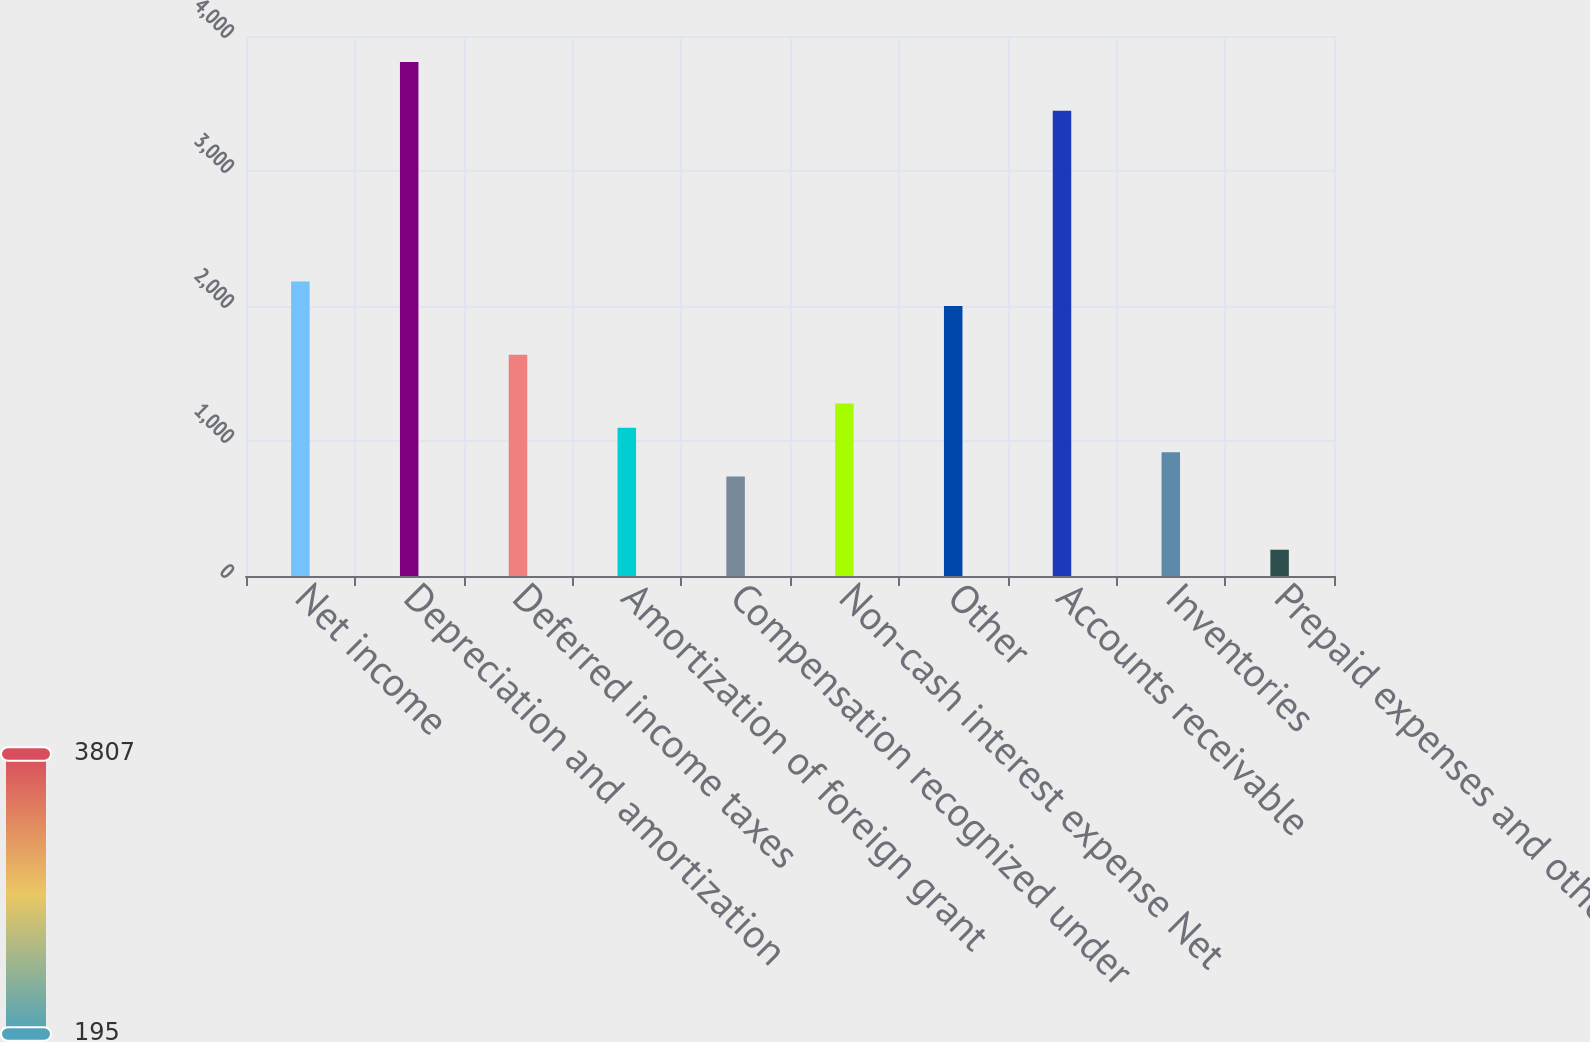<chart> <loc_0><loc_0><loc_500><loc_500><bar_chart><fcel>Net income<fcel>Depreciation and amortization<fcel>Deferred income taxes<fcel>Amortization of foreign grant<fcel>Compensation recognized under<fcel>Non-cash interest expense Net<fcel>Other<fcel>Accounts receivable<fcel>Inventories<fcel>Prepaid expenses and other<nl><fcel>2181.2<fcel>3806.6<fcel>1639.4<fcel>1097.6<fcel>736.4<fcel>1278.2<fcel>2000.6<fcel>3445.4<fcel>917<fcel>194.6<nl></chart> 